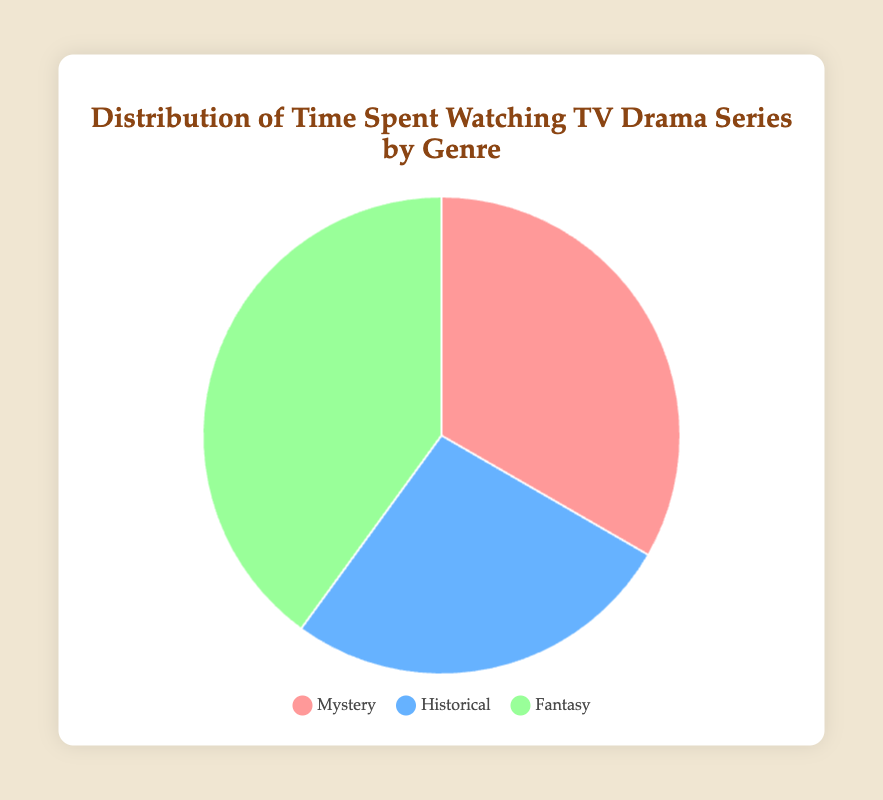What's the total amount of time spent watching TV drama series? Sum the time spent on each genre: Mystery (150 hours) + Historical (120 hours) + Fantasy (180 hours) = 450 hours in total.
Answer: 450 hours Which genre has the highest proportion of time spent watching? Compare the hours spent on each genre. Fantasy has 180 hours, which is more than both Mystery (150 hours) and Historical (120 hours).
Answer: Fantasy What percentage of total time is spent watching Historical series? Calculate the percentage of time spent on Historical series: (120 / 450) * 100 ≈ 26.7%.
Answer: 26.7% How much more time is spent watching Fantasy series compared to Mystery series? Subtract the time spent on Mystery from the time spent on Fantasy: 180 hours (Fantasy) - 150 hours (Mystery) = 30 hours.
Answer: 30 hours What is the average time spent watching TV drama series for the three genres? Sum the time spent on each genre and divide by the number of genres: (150 + 120 + 180) / 3 = 450 / 3 = 150 hours.
Answer: 150 hours Which genre does the pink section of the pie chart represent? The legend shows that the pink color corresponds to Mystery.
Answer: Mystery Is less time spent watching Historical series or Mystery series, and by how much? Subtract the time spent on Historical from the time spent on Mystery: 150 hours (Mystery) - 120 hours (Historical) = 30 hours.
Answer: Historical by 30 hours What is the difference between the highest and lowest percentage of time spent on genres? Calculate the percentage for each genre: Fantasy ≈ 40%, Mystery ≈ 33.3%, Historical ≈ 26.7%. Subtract the smallest percentage from the largest: 40% - 26.7% = 13.3%.
Answer: 13.3% What color is used to represent Fantasy series in the pie chart? The legend indicates that green is used for Fantasy series.
Answer: Green 